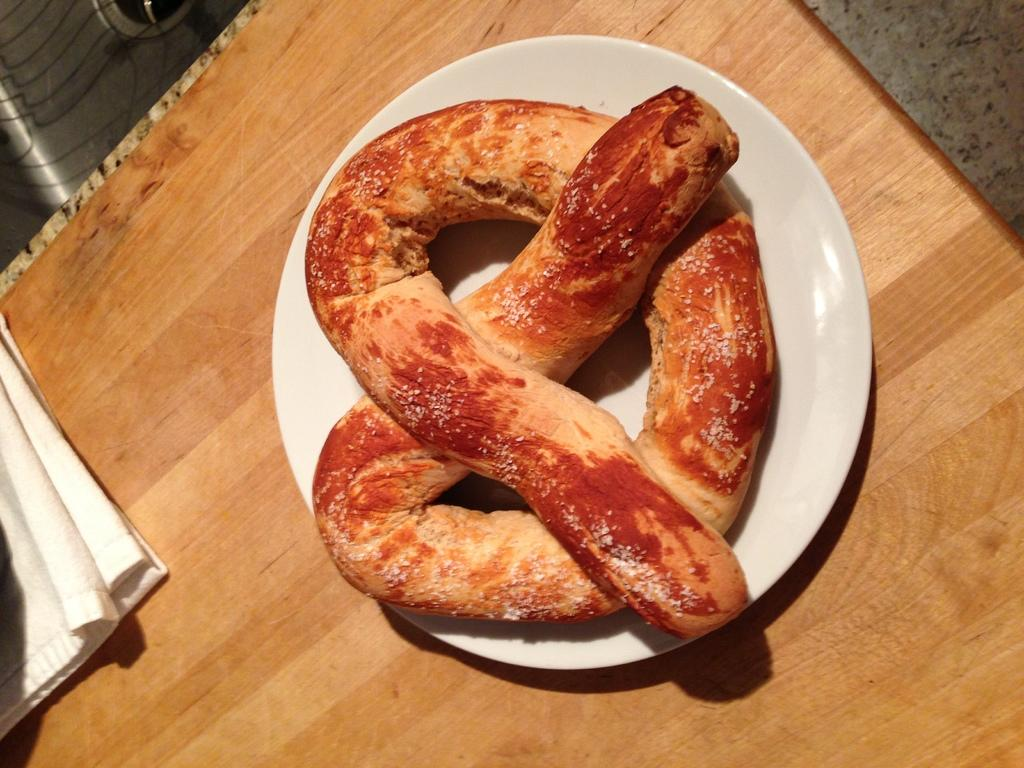What is the main food item visible in the image? There is a food item in a plate in the image. What item might be used for cleaning or wiping in the image? There is a napkin on the table in the image. Can you describe the setting where the image might have been taken? The image may have been taken in a room. How many friends are sitting with the dinosaurs in the image? There are no friends or dinosaurs present in the image. 